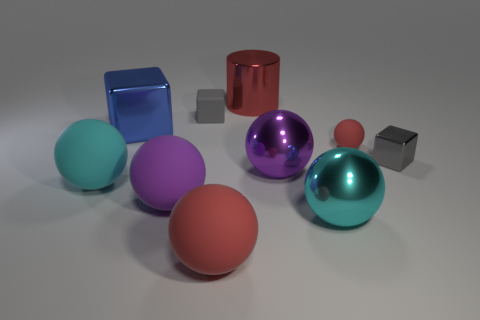There is a gray block behind the small shiny cube; how many gray cubes are in front of it?
Offer a terse response. 1. There is a cyan sphere that is to the right of the purple ball that is left of the large matte thing in front of the large purple rubber thing; how big is it?
Your answer should be very brief. Large. There is a shiny sphere on the left side of the large cyan metallic sphere; does it have the same color as the tiny ball?
Give a very brief answer. No. What is the size of the rubber thing that is the same shape as the large blue shiny object?
Offer a very short reply. Small. How many objects are tiny gray objects that are to the left of the cylinder or things that are left of the tiny red thing?
Ensure brevity in your answer.  8. There is a large metallic thing in front of the sphere to the left of the big blue shiny cube; what is its shape?
Make the answer very short. Sphere. Is there any other thing that is the same color as the tiny sphere?
Offer a very short reply. Yes. Is there anything else that is the same size as the purple metal thing?
Offer a very short reply. Yes. What number of objects are either large purple metal balls or purple metallic cylinders?
Offer a very short reply. 1. Are there any other gray matte blocks that have the same size as the gray matte block?
Give a very brief answer. No. 